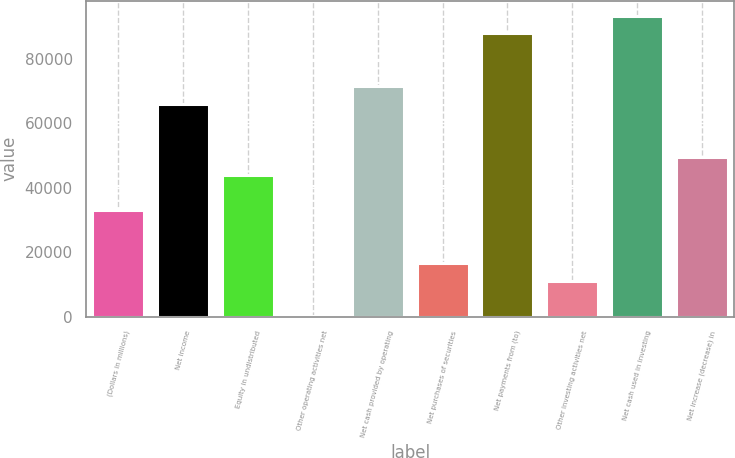Convert chart to OTSL. <chart><loc_0><loc_0><loc_500><loc_500><bar_chart><fcel>(Dollars in millions)<fcel>Net income<fcel>Equity in undistributed<fcel>Other operating activities net<fcel>Net cash provided by operating<fcel>Net purchases of securities<fcel>Net payments from (to)<fcel>Other investing activities net<fcel>Net cash used in investing<fcel>Net increase (decrease) in<nl><fcel>33103.8<fcel>65931.6<fcel>44046.4<fcel>276<fcel>71402.9<fcel>16689.9<fcel>87816.8<fcel>11218.6<fcel>93288.1<fcel>49517.7<nl></chart> 